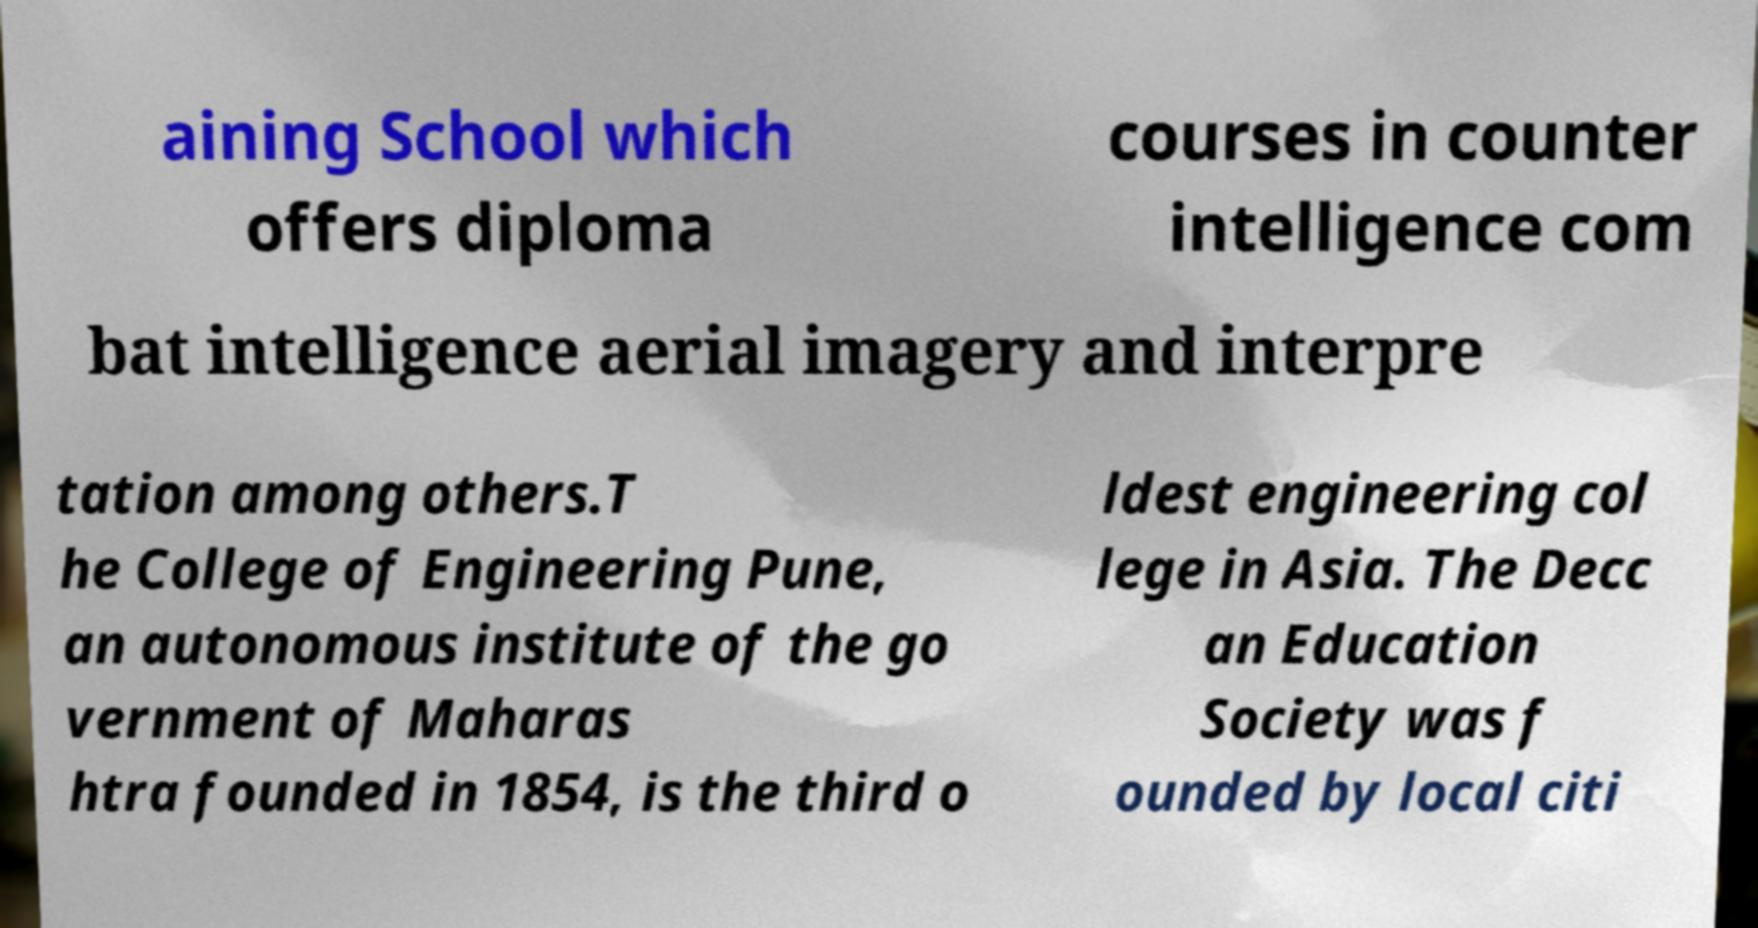What messages or text are displayed in this image? I need them in a readable, typed format. aining School which offers diploma courses in counter intelligence com bat intelligence aerial imagery and interpre tation among others.T he College of Engineering Pune, an autonomous institute of the go vernment of Maharas htra founded in 1854, is the third o ldest engineering col lege in Asia. The Decc an Education Society was f ounded by local citi 